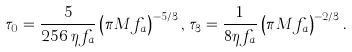<formula> <loc_0><loc_0><loc_500><loc_500>\tau _ { 0 } = \frac { 5 } { 2 5 6 \, \eta f _ { a } } \left ( \pi M f _ { a } \right ) ^ { - 5 / 3 } , \, \tau _ { 3 } = \frac { 1 } { 8 \eta f _ { a } } \left ( \pi M f _ { a } \right ) ^ { - 2 / 3 } .</formula> 